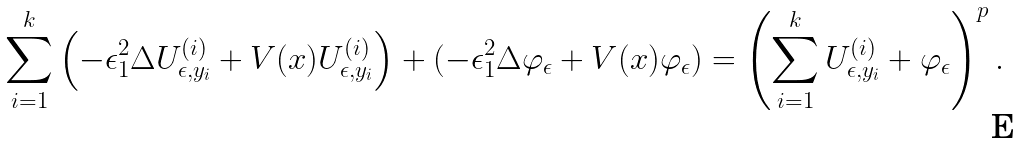<formula> <loc_0><loc_0><loc_500><loc_500>\sum _ { i = 1 } ^ { k } \left ( - \epsilon _ { 1 } ^ { 2 } \Delta U _ { \epsilon , y _ { i } } ^ { ( i ) } + V ( x ) U _ { \epsilon , y _ { i } } ^ { ( i ) } \right ) + ( - \epsilon _ { 1 } ^ { 2 } \Delta \varphi _ { \epsilon } + V ( x ) \varphi _ { \epsilon } ) = \left ( \sum _ { i = 1 } ^ { k } U _ { \epsilon , y _ { i } } ^ { ( i ) } + \varphi _ { \epsilon } \right ) ^ { p } .</formula> 